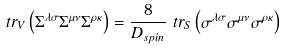<formula> <loc_0><loc_0><loc_500><loc_500>\ t r _ { V } \left ( \Sigma ^ { \lambda \sigma } \Sigma ^ { \mu \nu } \Sigma ^ { \rho \kappa } \right ) & = \frac { 8 } { D _ { s p i n } } \ t r _ { S } \left ( \sigma ^ { \lambda \sigma } \sigma ^ { \mu \nu } \sigma ^ { \rho \kappa } \right )</formula> 